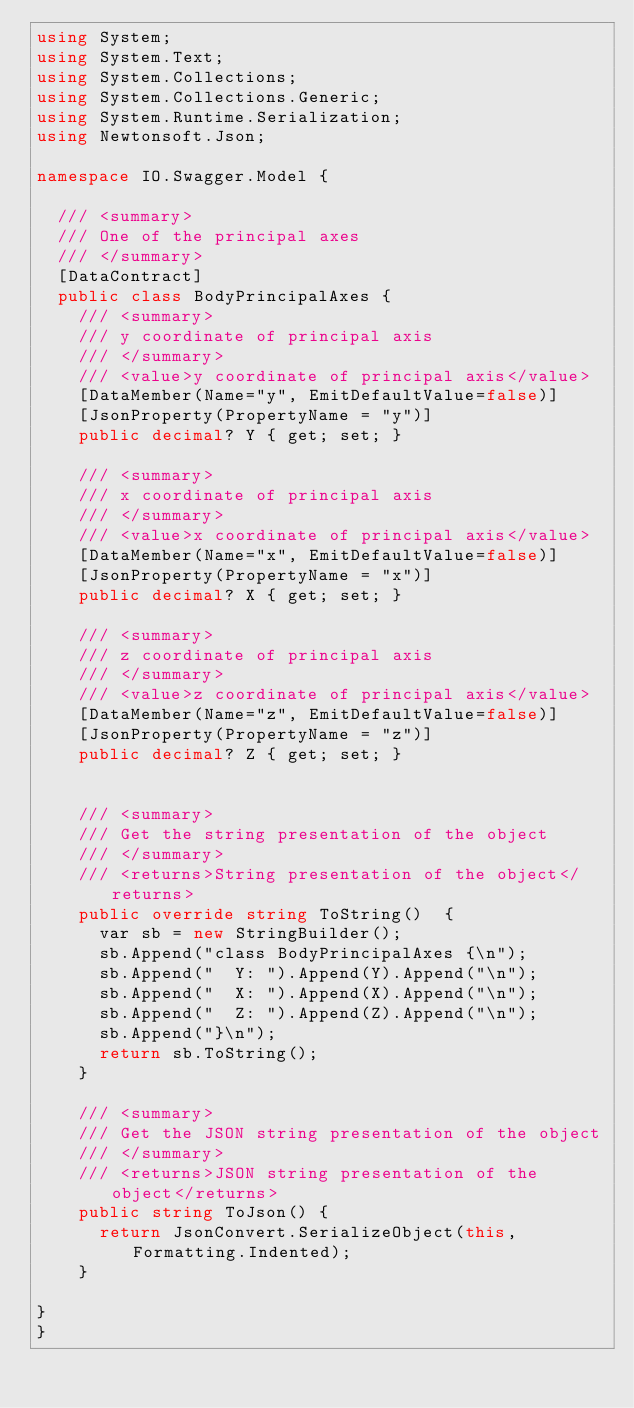<code> <loc_0><loc_0><loc_500><loc_500><_C#_>using System;
using System.Text;
using System.Collections;
using System.Collections.Generic;
using System.Runtime.Serialization;
using Newtonsoft.Json;

namespace IO.Swagger.Model {

  /// <summary>
  /// One of the principal axes
  /// </summary>
  [DataContract]
  public class BodyPrincipalAxes {
    /// <summary>
    /// y coordinate of principal axis
    /// </summary>
    /// <value>y coordinate of principal axis</value>
    [DataMember(Name="y", EmitDefaultValue=false)]
    [JsonProperty(PropertyName = "y")]
    public decimal? Y { get; set; }

    /// <summary>
    /// x coordinate of principal axis
    /// </summary>
    /// <value>x coordinate of principal axis</value>
    [DataMember(Name="x", EmitDefaultValue=false)]
    [JsonProperty(PropertyName = "x")]
    public decimal? X { get; set; }

    /// <summary>
    /// z coordinate of principal axis
    /// </summary>
    /// <value>z coordinate of principal axis</value>
    [DataMember(Name="z", EmitDefaultValue=false)]
    [JsonProperty(PropertyName = "z")]
    public decimal? Z { get; set; }


    /// <summary>
    /// Get the string presentation of the object
    /// </summary>
    /// <returns>String presentation of the object</returns>
    public override string ToString()  {
      var sb = new StringBuilder();
      sb.Append("class BodyPrincipalAxes {\n");
      sb.Append("  Y: ").Append(Y).Append("\n");
      sb.Append("  X: ").Append(X).Append("\n");
      sb.Append("  Z: ").Append(Z).Append("\n");
      sb.Append("}\n");
      return sb.ToString();
    }

    /// <summary>
    /// Get the JSON string presentation of the object
    /// </summary>
    /// <returns>JSON string presentation of the object</returns>
    public string ToJson() {
      return JsonConvert.SerializeObject(this, Formatting.Indented);
    }

}
}
</code> 